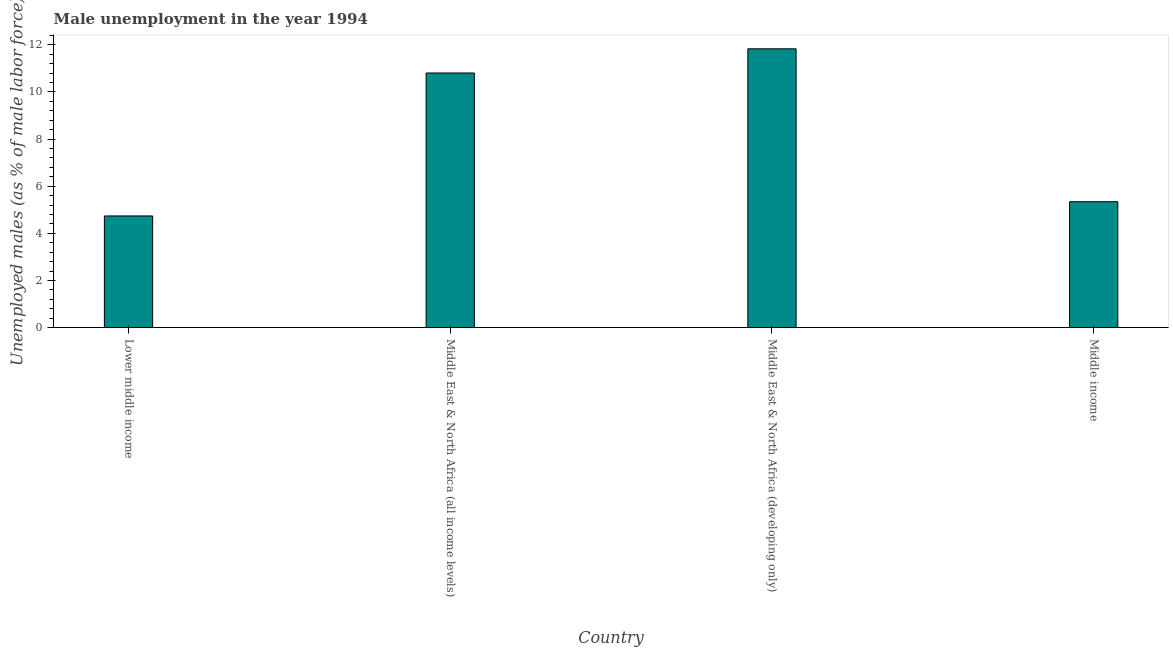Does the graph contain grids?
Provide a short and direct response. No. What is the title of the graph?
Provide a succinct answer. Male unemployment in the year 1994. What is the label or title of the X-axis?
Give a very brief answer. Country. What is the label or title of the Y-axis?
Your answer should be compact. Unemployed males (as % of male labor force). What is the unemployed males population in Middle East & North Africa (all income levels)?
Your response must be concise. 10.8. Across all countries, what is the maximum unemployed males population?
Keep it short and to the point. 11.83. Across all countries, what is the minimum unemployed males population?
Your answer should be compact. 4.74. In which country was the unemployed males population maximum?
Ensure brevity in your answer.  Middle East & North Africa (developing only). In which country was the unemployed males population minimum?
Provide a succinct answer. Lower middle income. What is the sum of the unemployed males population?
Offer a very short reply. 32.72. What is the difference between the unemployed males population in Middle East & North Africa (all income levels) and Middle income?
Provide a short and direct response. 5.46. What is the average unemployed males population per country?
Offer a terse response. 8.18. What is the median unemployed males population?
Your response must be concise. 8.07. What is the ratio of the unemployed males population in Middle East & North Africa (all income levels) to that in Middle income?
Your answer should be compact. 2.02. Is the unemployed males population in Middle East & North Africa (developing only) less than that in Middle income?
Provide a short and direct response. No. Is the difference between the unemployed males population in Lower middle income and Middle East & North Africa (developing only) greater than the difference between any two countries?
Give a very brief answer. Yes. What is the difference between the highest and the second highest unemployed males population?
Provide a short and direct response. 1.03. Is the sum of the unemployed males population in Lower middle income and Middle East & North Africa (all income levels) greater than the maximum unemployed males population across all countries?
Provide a short and direct response. Yes. What is the difference between the highest and the lowest unemployed males population?
Your answer should be very brief. 7.09. In how many countries, is the unemployed males population greater than the average unemployed males population taken over all countries?
Make the answer very short. 2. How many bars are there?
Offer a very short reply. 4. Are all the bars in the graph horizontal?
Offer a terse response. No. How many countries are there in the graph?
Your answer should be compact. 4. What is the Unemployed males (as % of male labor force) in Lower middle income?
Provide a short and direct response. 4.74. What is the Unemployed males (as % of male labor force) of Middle East & North Africa (all income levels)?
Make the answer very short. 10.8. What is the Unemployed males (as % of male labor force) of Middle East & North Africa (developing only)?
Offer a very short reply. 11.83. What is the Unemployed males (as % of male labor force) of Middle income?
Your answer should be very brief. 5.34. What is the difference between the Unemployed males (as % of male labor force) in Lower middle income and Middle East & North Africa (all income levels)?
Your response must be concise. -6.06. What is the difference between the Unemployed males (as % of male labor force) in Lower middle income and Middle East & North Africa (developing only)?
Offer a very short reply. -7.09. What is the difference between the Unemployed males (as % of male labor force) in Lower middle income and Middle income?
Provide a short and direct response. -0.6. What is the difference between the Unemployed males (as % of male labor force) in Middle East & North Africa (all income levels) and Middle East & North Africa (developing only)?
Your response must be concise. -1.03. What is the difference between the Unemployed males (as % of male labor force) in Middle East & North Africa (all income levels) and Middle income?
Keep it short and to the point. 5.46. What is the difference between the Unemployed males (as % of male labor force) in Middle East & North Africa (developing only) and Middle income?
Give a very brief answer. 6.49. What is the ratio of the Unemployed males (as % of male labor force) in Lower middle income to that in Middle East & North Africa (all income levels)?
Your answer should be compact. 0.44. What is the ratio of the Unemployed males (as % of male labor force) in Lower middle income to that in Middle East & North Africa (developing only)?
Offer a terse response. 0.4. What is the ratio of the Unemployed males (as % of male labor force) in Lower middle income to that in Middle income?
Your response must be concise. 0.89. What is the ratio of the Unemployed males (as % of male labor force) in Middle East & North Africa (all income levels) to that in Middle income?
Your response must be concise. 2.02. What is the ratio of the Unemployed males (as % of male labor force) in Middle East & North Africa (developing only) to that in Middle income?
Make the answer very short. 2.21. 